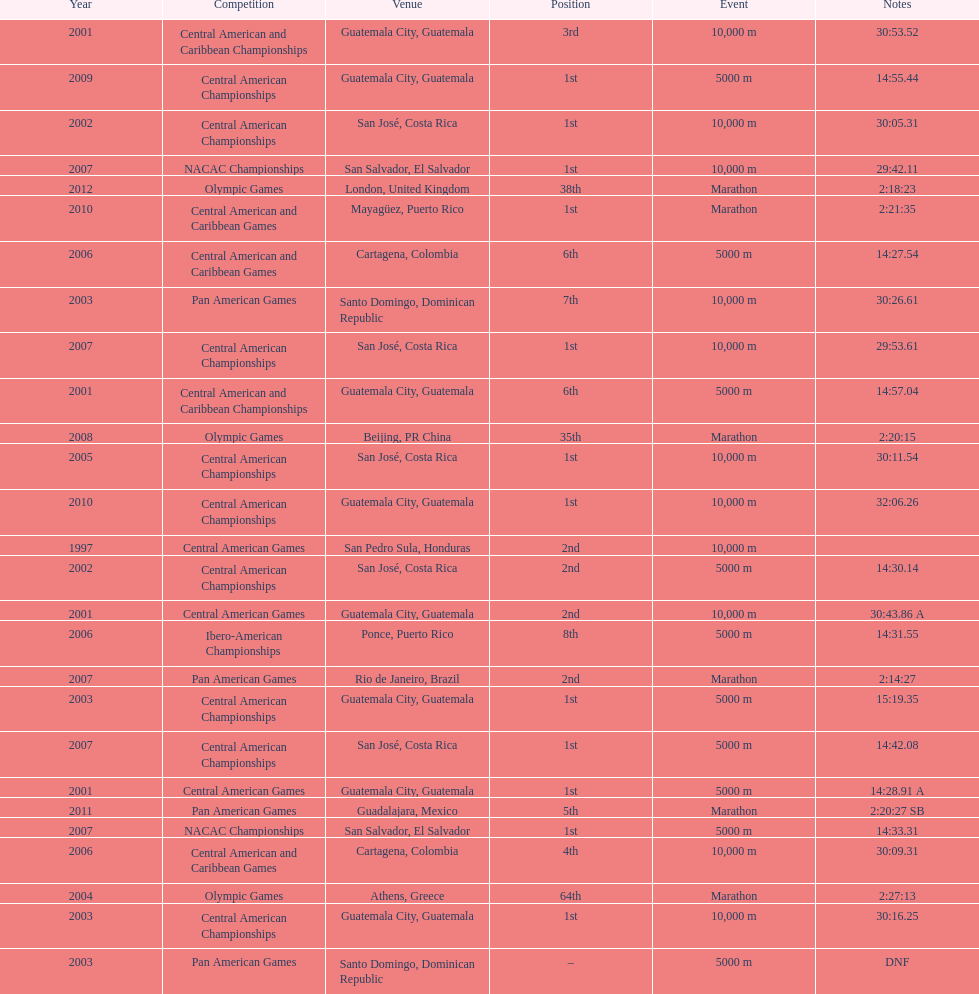How often has this athlete been unable to finish a competition? 1. 